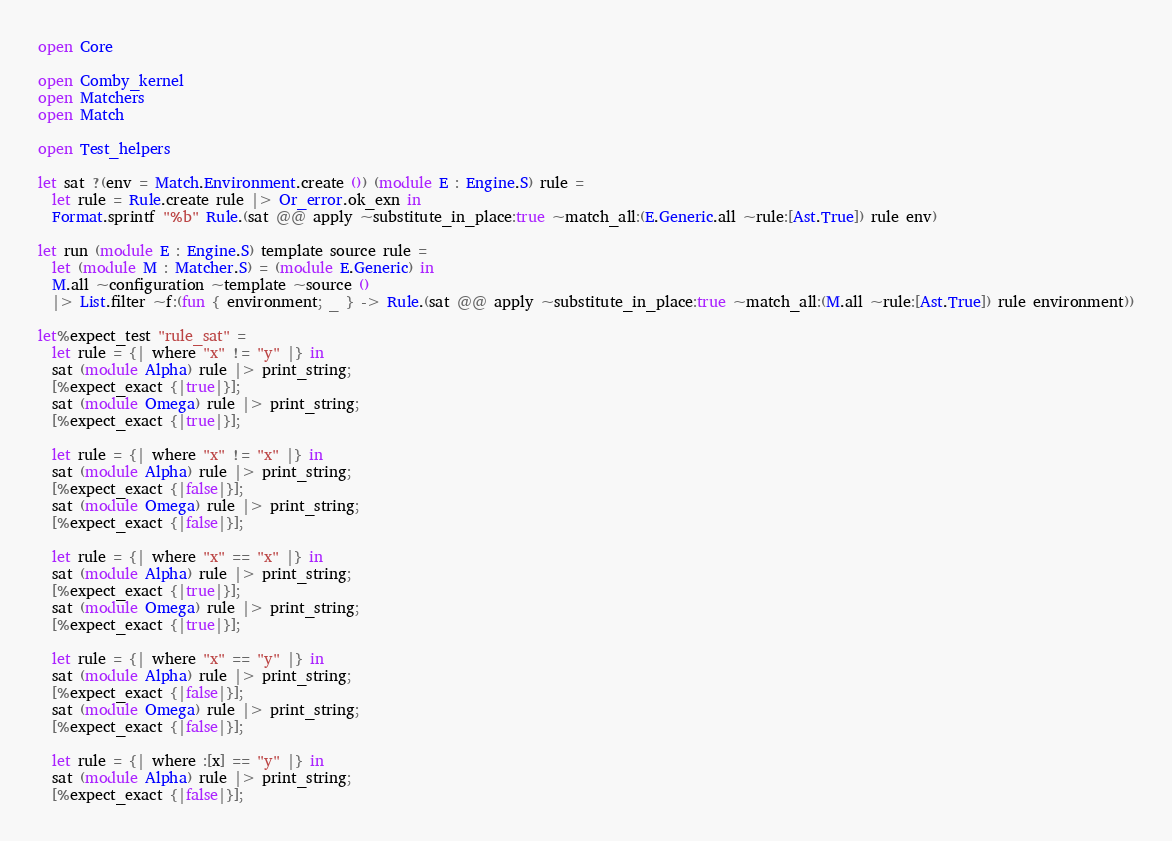<code> <loc_0><loc_0><loc_500><loc_500><_OCaml_>open Core

open Comby_kernel
open Matchers
open Match

open Test_helpers

let sat ?(env = Match.Environment.create ()) (module E : Engine.S) rule =
  let rule = Rule.create rule |> Or_error.ok_exn in
  Format.sprintf "%b" Rule.(sat @@ apply ~substitute_in_place:true ~match_all:(E.Generic.all ~rule:[Ast.True]) rule env)

let run (module E : Engine.S) template source rule =
  let (module M : Matcher.S) = (module E.Generic) in
  M.all ~configuration ~template ~source ()
  |> List.filter ~f:(fun { environment; _ } -> Rule.(sat @@ apply ~substitute_in_place:true ~match_all:(M.all ~rule:[Ast.True]) rule environment))

let%expect_test "rule_sat" =
  let rule = {| where "x" != "y" |} in
  sat (module Alpha) rule |> print_string;
  [%expect_exact {|true|}];
  sat (module Omega) rule |> print_string;
  [%expect_exact {|true|}];

  let rule = {| where "x" != "x" |} in
  sat (module Alpha) rule |> print_string;
  [%expect_exact {|false|}];
  sat (module Omega) rule |> print_string;
  [%expect_exact {|false|}];

  let rule = {| where "x" == "x" |} in
  sat (module Alpha) rule |> print_string;
  [%expect_exact {|true|}];
  sat (module Omega) rule |> print_string;
  [%expect_exact {|true|}];

  let rule = {| where "x" == "y" |} in
  sat (module Alpha) rule |> print_string;
  [%expect_exact {|false|}];
  sat (module Omega) rule |> print_string;
  [%expect_exact {|false|}];

  let rule = {| where :[x] == "y" |} in
  sat (module Alpha) rule |> print_string;
  [%expect_exact {|false|}];</code> 